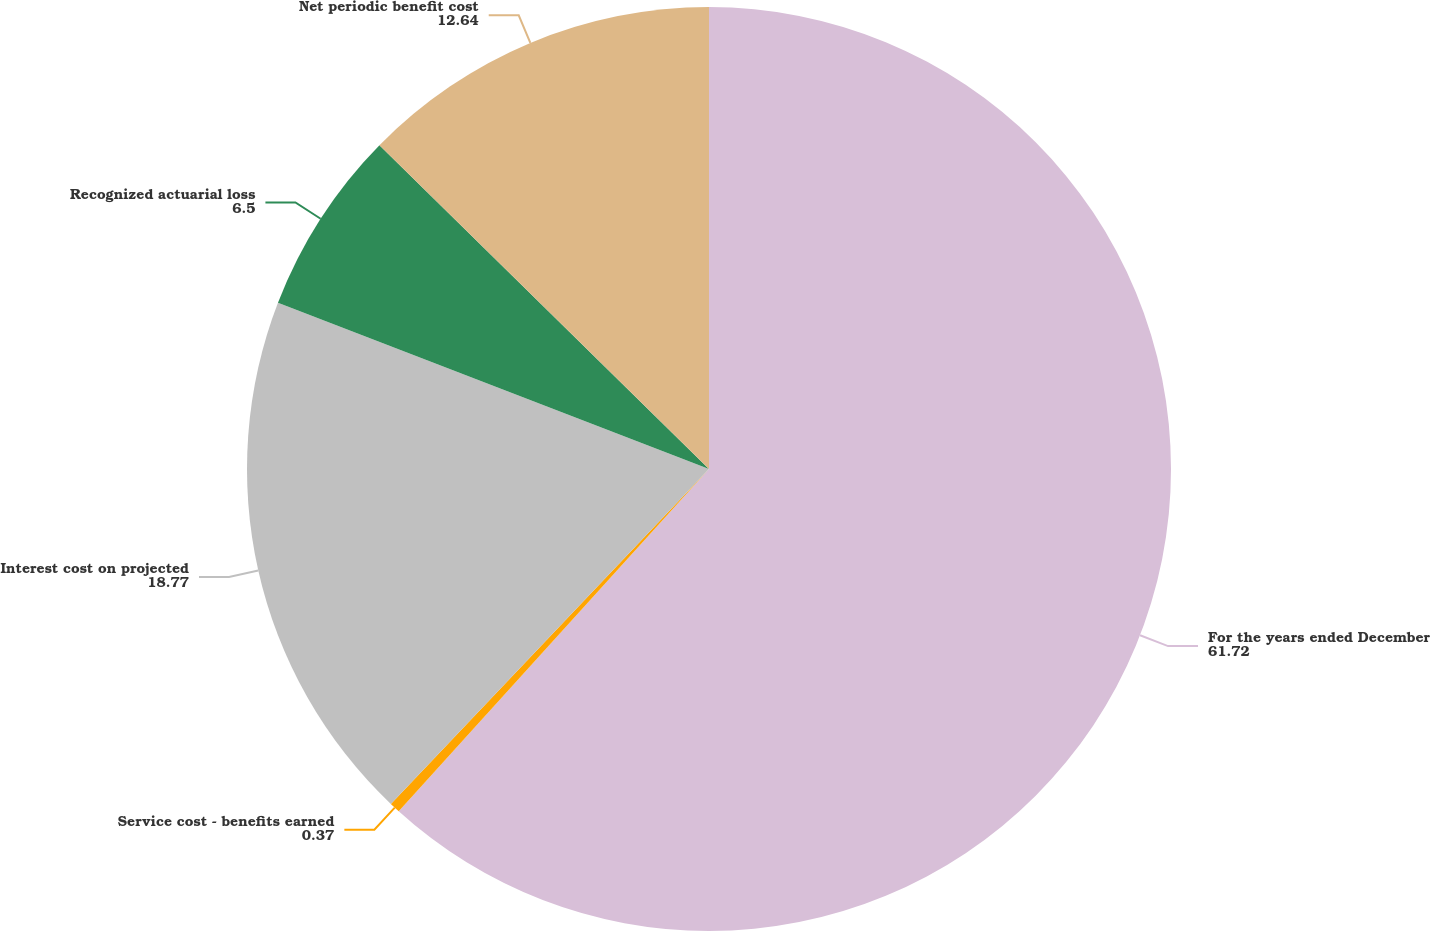<chart> <loc_0><loc_0><loc_500><loc_500><pie_chart><fcel>For the years ended December<fcel>Service cost - benefits earned<fcel>Interest cost on projected<fcel>Recognized actuarial loss<fcel>Net periodic benefit cost<nl><fcel>61.72%<fcel>0.37%<fcel>18.77%<fcel>6.5%<fcel>12.64%<nl></chart> 